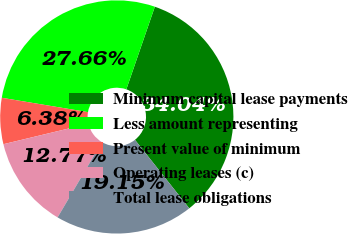Convert chart to OTSL. <chart><loc_0><loc_0><loc_500><loc_500><pie_chart><fcel>Minimum capital lease payments<fcel>Less amount representing<fcel>Present value of minimum<fcel>Operating leases (c)<fcel>Total lease obligations<nl><fcel>34.04%<fcel>27.66%<fcel>6.38%<fcel>12.77%<fcel>19.15%<nl></chart> 